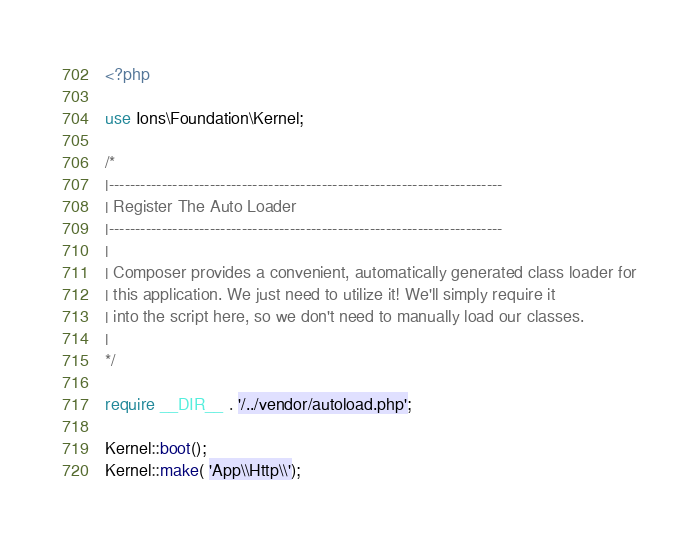Convert code to text. <code><loc_0><loc_0><loc_500><loc_500><_PHP_><?php

use Ions\Foundation\Kernel;

/*
|--------------------------------------------------------------------------
| Register The Auto Loader
|--------------------------------------------------------------------------
|
| Composer provides a convenient, automatically generated class loader for
| this application. We just need to utilize it! We'll simply require it
| into the script here, so we don't need to manually load our classes.
|
*/

require __DIR__ . '/../vendor/autoload.php';

Kernel::boot();
Kernel::make( 'App\\Http\\');</code> 